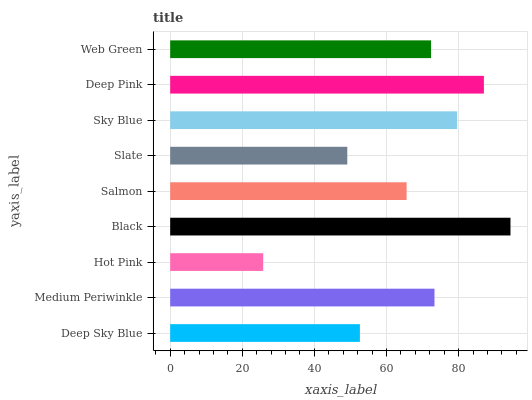Is Hot Pink the minimum?
Answer yes or no. Yes. Is Black the maximum?
Answer yes or no. Yes. Is Medium Periwinkle the minimum?
Answer yes or no. No. Is Medium Periwinkle the maximum?
Answer yes or no. No. Is Medium Periwinkle greater than Deep Sky Blue?
Answer yes or no. Yes. Is Deep Sky Blue less than Medium Periwinkle?
Answer yes or no. Yes. Is Deep Sky Blue greater than Medium Periwinkle?
Answer yes or no. No. Is Medium Periwinkle less than Deep Sky Blue?
Answer yes or no. No. Is Web Green the high median?
Answer yes or no. Yes. Is Web Green the low median?
Answer yes or no. Yes. Is Deep Sky Blue the high median?
Answer yes or no. No. Is Black the low median?
Answer yes or no. No. 